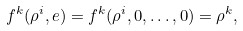<formula> <loc_0><loc_0><loc_500><loc_500>f ^ { k } ( \rho ^ { i } , e ) = f ^ { k } ( \rho ^ { i } , 0 , \dots , 0 ) = \rho ^ { k } ,</formula> 